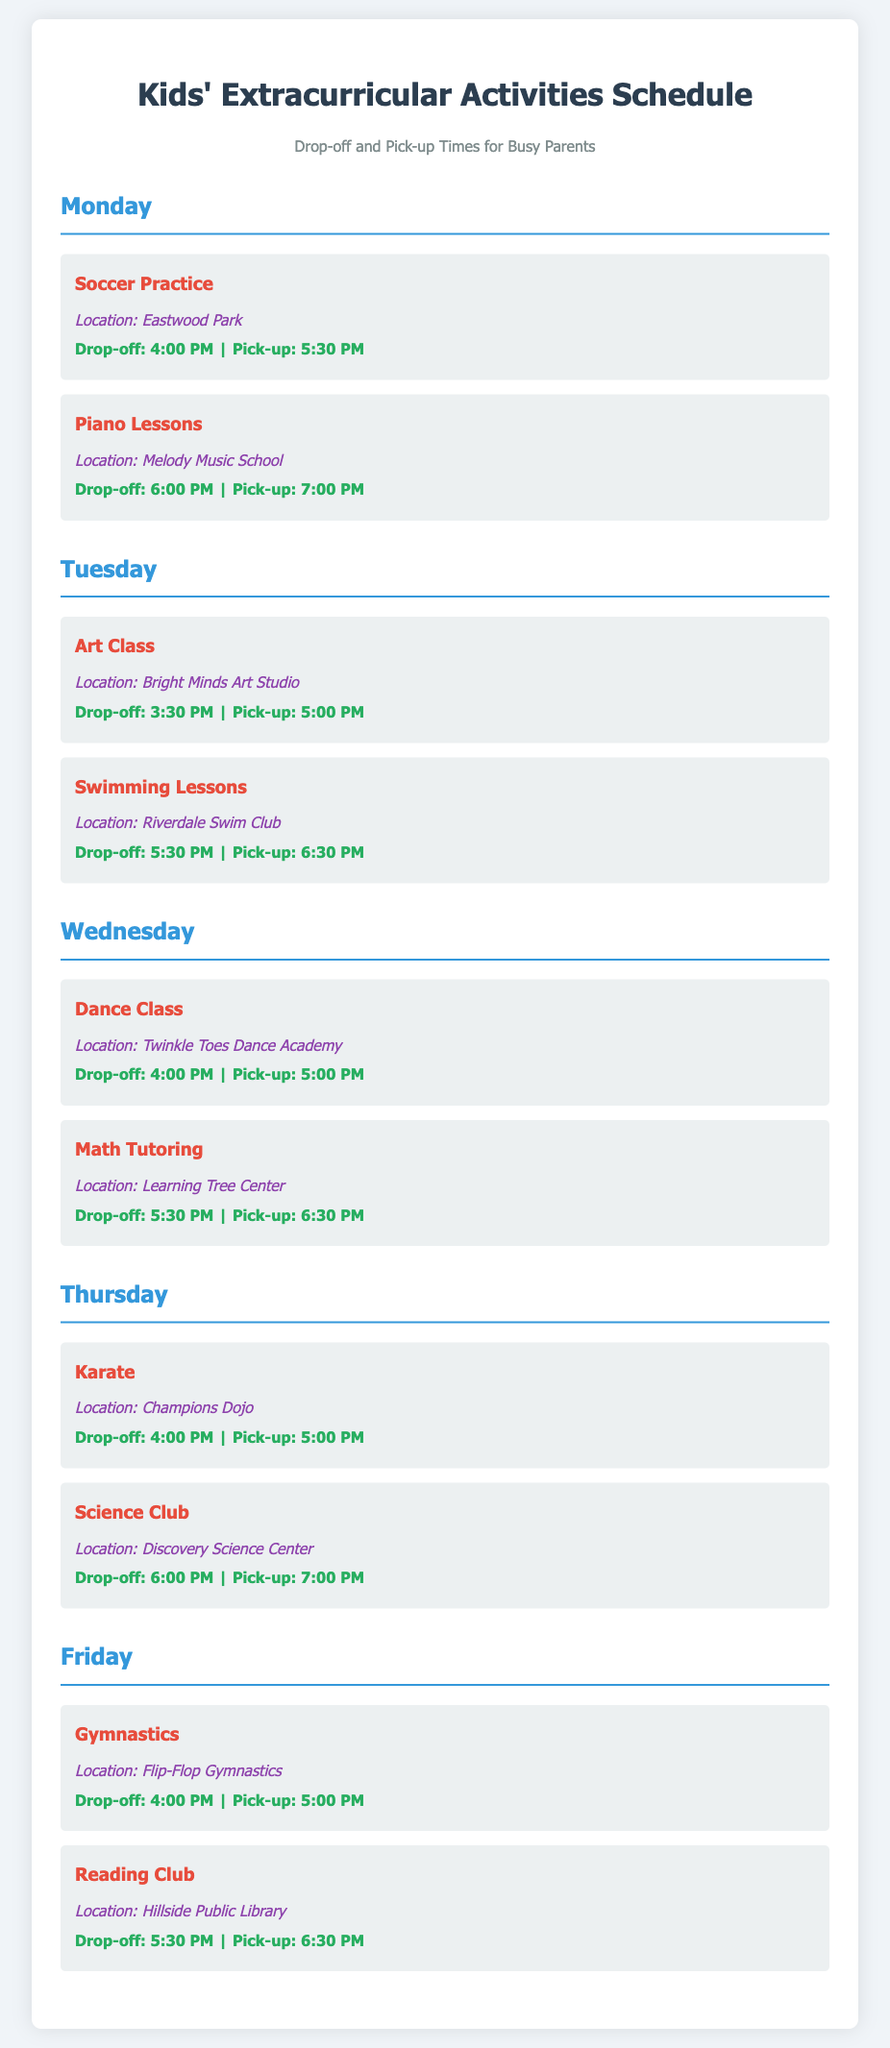What activities are scheduled for Monday? The activities listed for Monday are Soccer Practice and Piano Lessons.
Answer: Soccer Practice, Piano Lessons What is the location for Dance Class? The location for Dance Class on Wednesday is Twinkle Toes Dance Academy.
Answer: Twinkle Toes Dance Academy What time is the pick-up for Karate on Thursday? The pick-up time for Karate on Thursday is 5:00 PM.
Answer: 5:00 PM How many activities are scheduled on Tuesday? There are two activities scheduled on Tuesday: Art Class and Swimming Lessons.
Answer: 2 Which activity occurs at Riverdale Swim Club? The activity at Riverdale Swim Club is Swimming Lessons.
Answer: Swimming Lessons What is the earliest drop-off time on Friday? The earliest drop-off time on Friday is for Gymnastics, which is at 4:00 PM.
Answer: 4:00 PM Which day has both drop-off times starting with the same hour? Monday and Thursday both have a drop-off time of 4:00 PM.
Answer: Monday, Thursday What is the last activity scheduled for the week? The last activity scheduled for the week is Reading Club on Friday.
Answer: Reading Club 